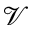<formula> <loc_0><loc_0><loc_500><loc_500>\mathcal { V }</formula> 